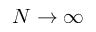Convert formula to latex. <formula><loc_0><loc_0><loc_500><loc_500>N \rightarrow \infty</formula> 